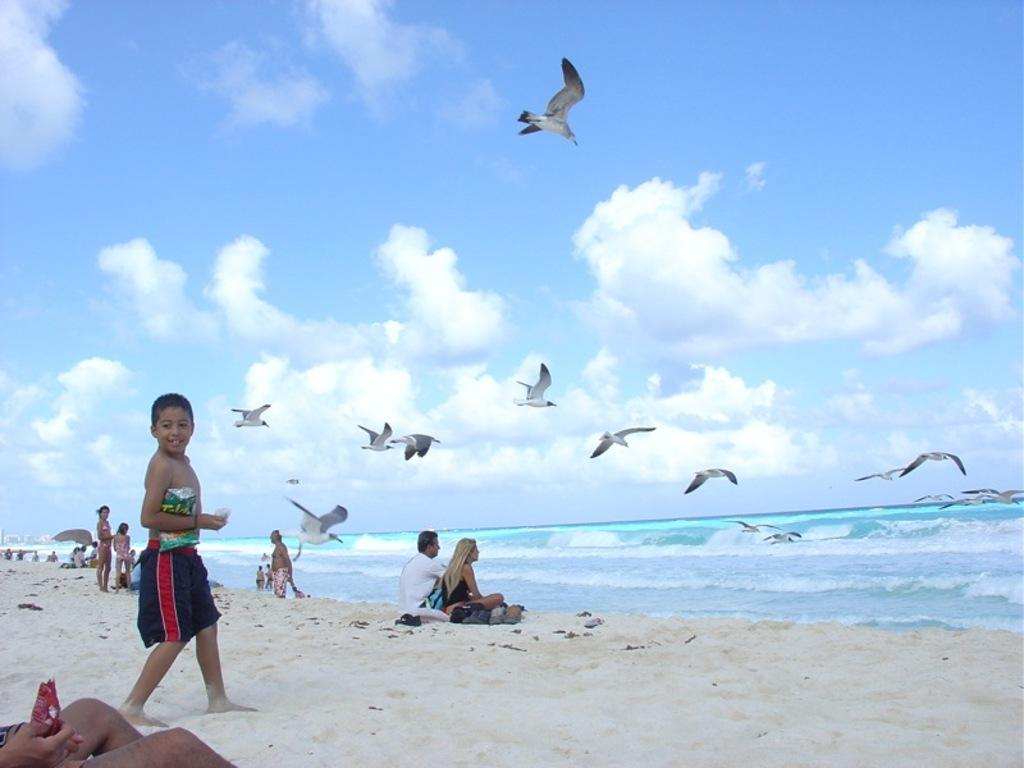What is the boy doing on the left side of the image? The boy is walking on the sand on the left side of the image. What can be seen in the middle of the image? There are birds flying in the middle of the image. What type of location is depicted on the right side of the image? There is a beach on the right side of the image. What is visible at the top of the image? The sky is visible at the top of the image. Who is the owner of the ball that is visible in the image? There is no ball present in the image. How many passengers are visible in the image? There are no passengers present in the image. 